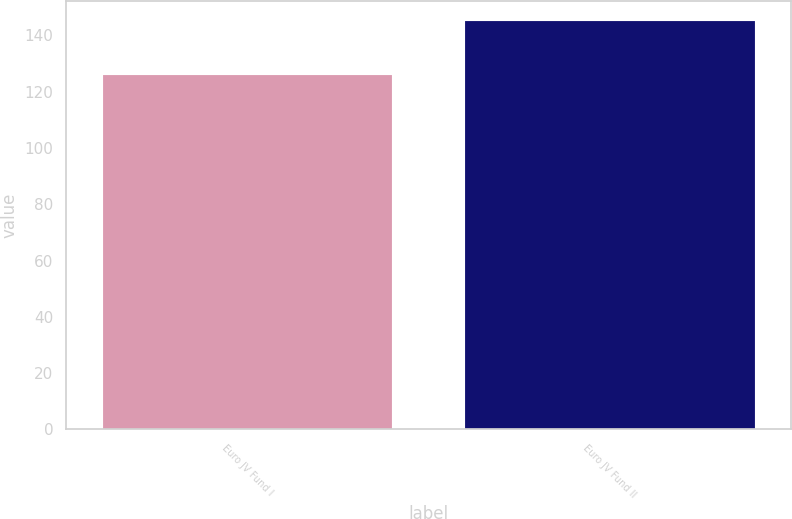Convert chart to OTSL. <chart><loc_0><loc_0><loc_500><loc_500><bar_chart><fcel>Euro JV Fund I<fcel>Euro JV Fund II<nl><fcel>126<fcel>145<nl></chart> 